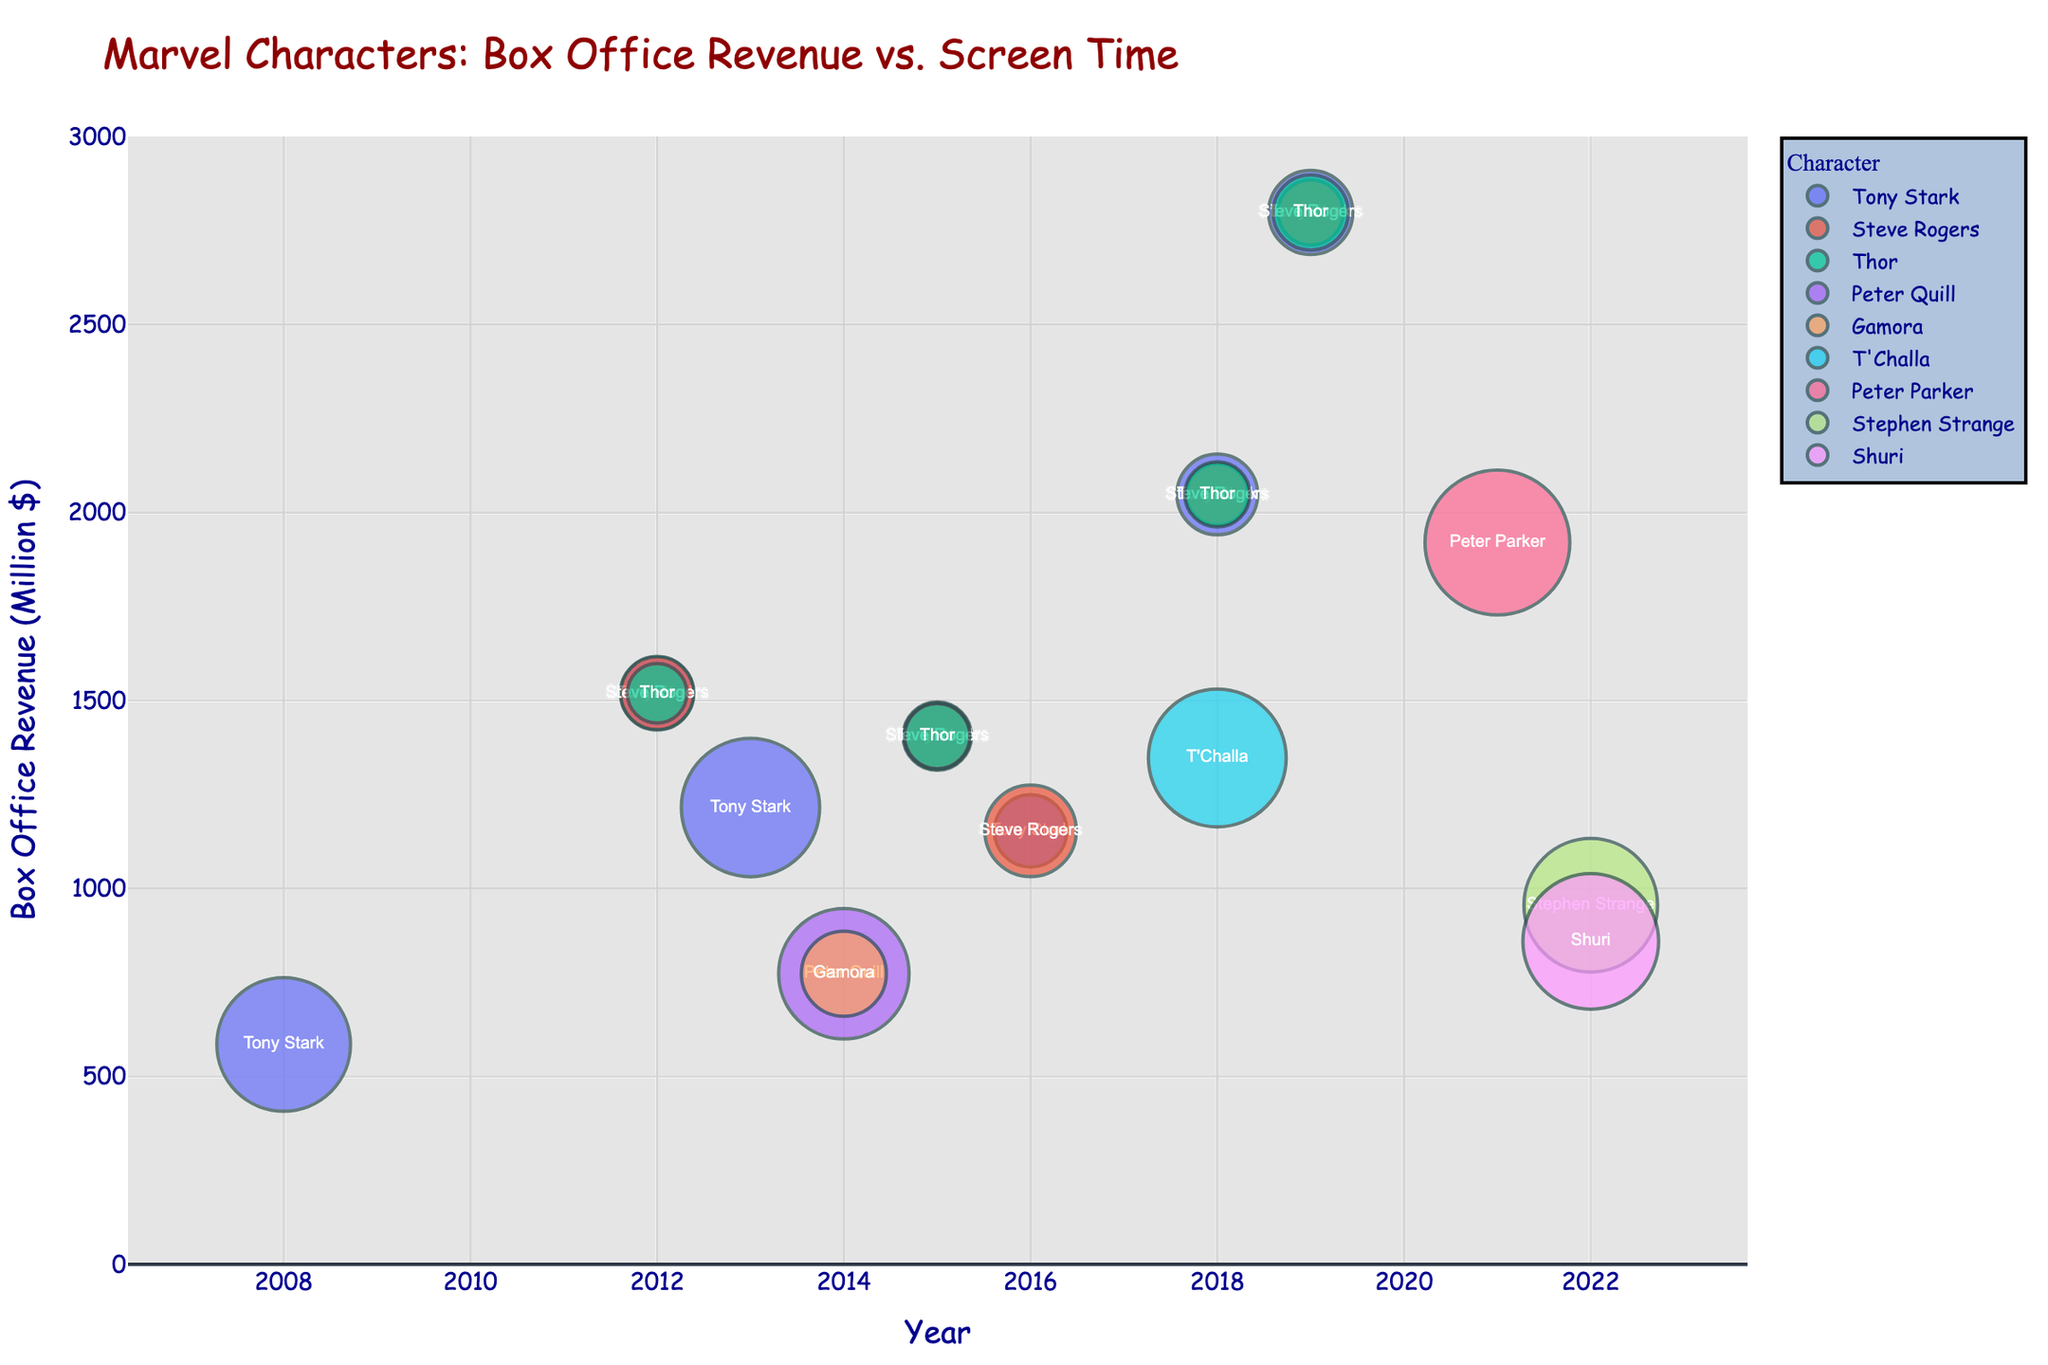What's the title of the chart? The title of the chart is located at the top of the figure and usually provides a summary of what the chart is about.
Answer: Marvel Characters: Box Office Revenue vs. Screen Time Which character has the highest screen time, and in which movie? By observing the size of the bubbles, the largest bubble corresponds to the character with the highest screen time. This bubble is for Peter Parker in "Spider-Man: No Way Home".
Answer: Peter Parker in Spider-Man: No Way Home In what year did "Avengers: Endgame" release and what's its box office revenue? The x-axis shows the year, and the hover label provides the movie name and other details. The bubble for "Avengers: Endgame" is positioned at the year 2019 on the x-axis and has a box office revenue bubble value at around 2798 million dollars.
Answer: 2019, 2798 Million$ Which character appears most frequently in this dataset, and how many times do they appear? By looking at the color and label of each bubble, Tony Stark appears multiple times. Counting them reveals that he appears 6 times.
Answer: Tony Stark, 6 times Compare the box office revenue of "Black Panther" in 2018 and "Black Panther: Wakanda Forever" in 2022, which one was higher? Locate the bubbles corresponding to these movies and compare their positions on the y-axis. "Black Panther" (2018) has a higher position at 1347 million dollars compared to "Black Panther: Wakanda Forever" (2022) which is at 859 million dollars.
Answer: Black Panther (2018) What's the overall trend of box office revenue for Iron Man movies from 2008 to 2016? Visualize the bubbles corresponding to Tony Stark in "Iron Man" (2008), "Iron Man 3" (2013), and "Captain America: Civil War" (2016). The box office revenue increases from 585 million dollars in 2008 to 1215 million dollars in 2013 and then a little drop to 1153 million dollars in 2016.
Answer: Generally increasing, then a slight decrease What's the difference in screen time between Tony Stark in "Iron Man 3" and Tony Stark in "Avengers: Endgame"? Look at the size of the bubbles and the hover text for screen time details. Tony Stark has 135 minutes in "Iron Man 3" and 50 minutes in "Avengers: Endgame". The difference is 135 - 50 = 85 minutes.
Answer: 85 minutes Which movie has the highest box office revenue, and which character is associated with the most screen time in that movie? Find the highest bubble on the y-axis representing 2798 million dollars, which corresponds to "Avengers: Endgame". The hover text reveals Tony Stark with the most screen time of 50 minutes in that movie.
Answer: Avengers: Endgame, Tony Stark How many data points are there in the plot? Count the total number of bubbles representing different characters and movies.
Answer: 21 What is the screen time of Steve Rogers in "Avengers: Age of Ultron", and how does it compare to Thor in the same movie? Check the hover text for both Steve Rogers and Thor in "Avengers: Age of Ultron". Steve Rogers has 31 minutes, while Thor has 30 minutes.
Answer: Steve Rogers: 31 minutes, Thor: 30 minutes 